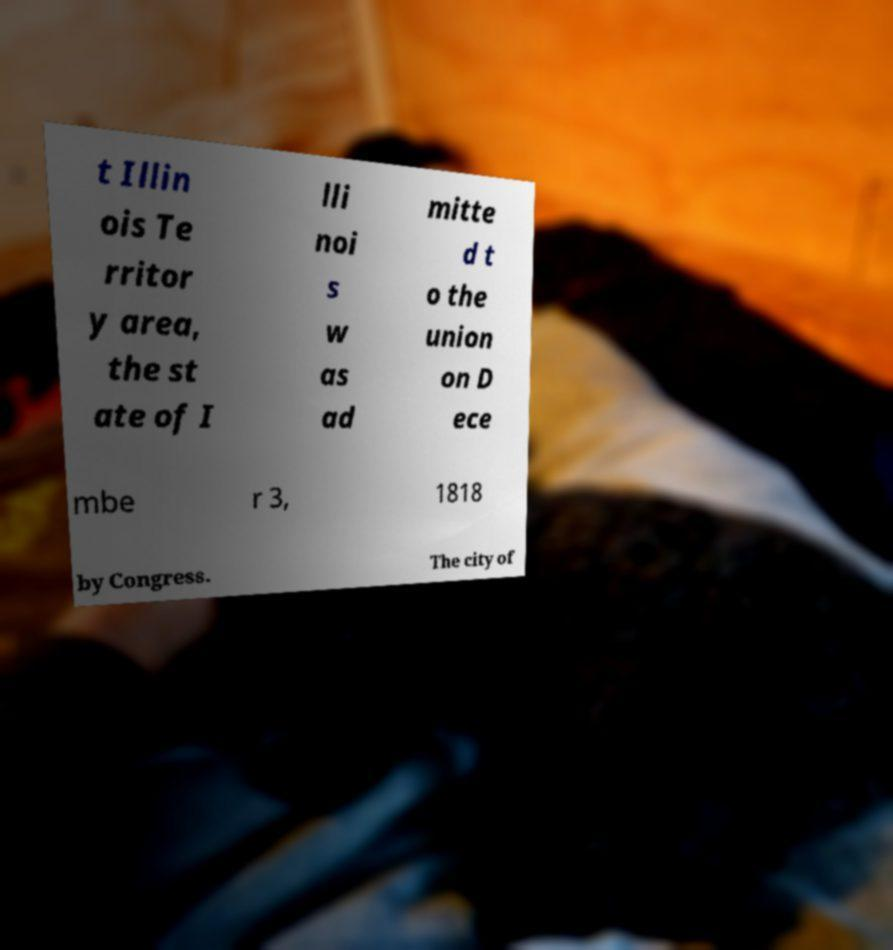Please read and relay the text visible in this image. What does it say? t Illin ois Te rritor y area, the st ate of I lli noi s w as ad mitte d t o the union on D ece mbe r 3, 1818 by Congress. The city of 